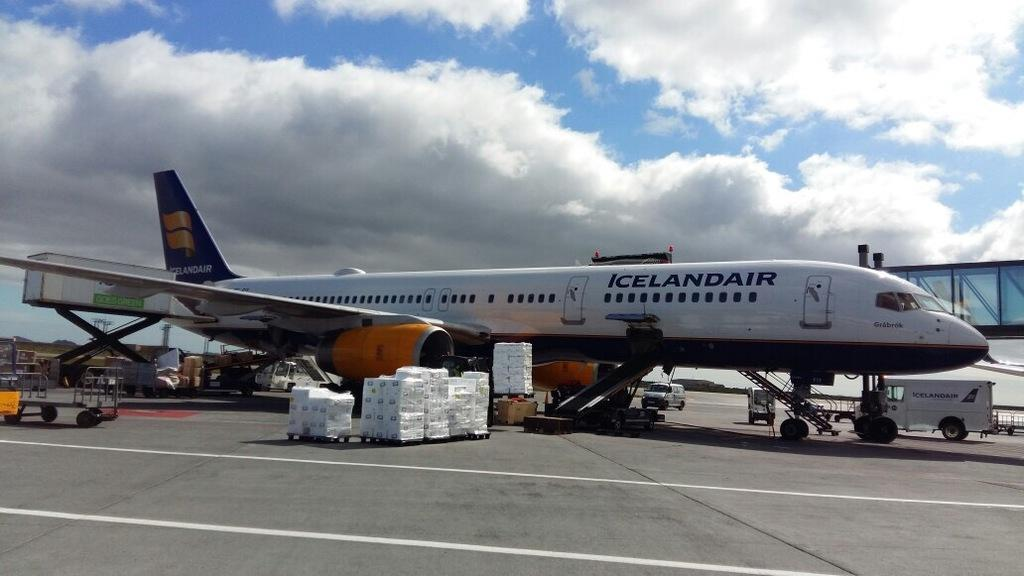<image>
Render a clear and concise summary of the photo. An airplane from the company Iceland Air on the ground 